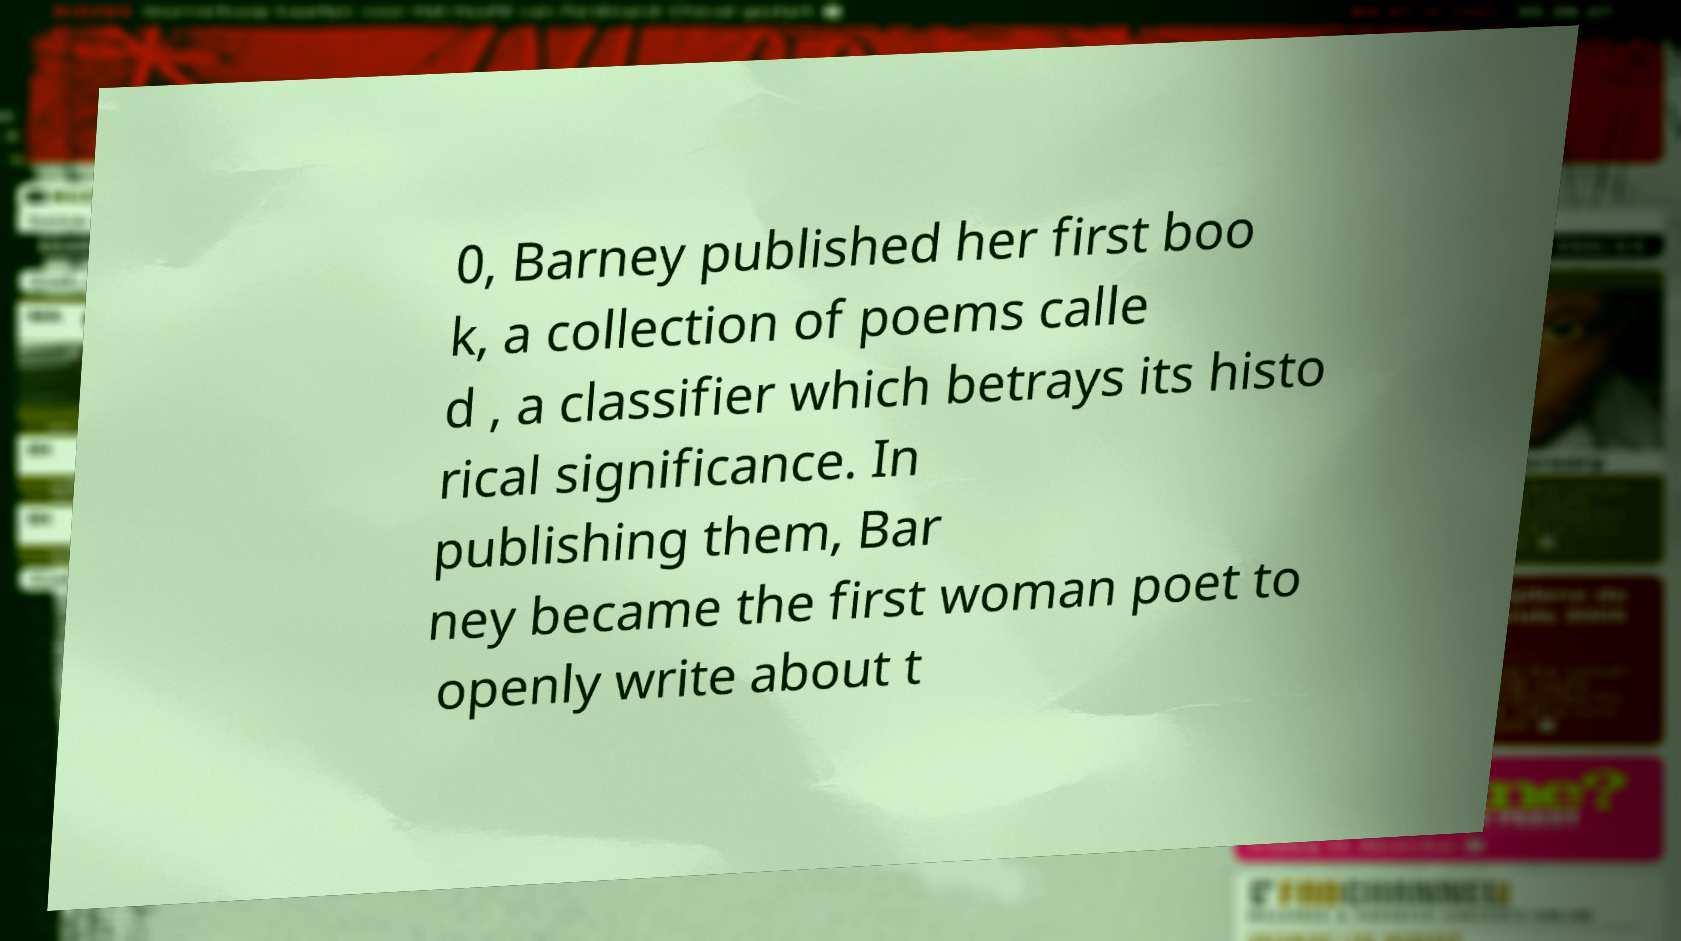Could you assist in decoding the text presented in this image and type it out clearly? 0, Barney published her first boo k, a collection of poems calle d , a classifier which betrays its histo rical significance. In publishing them, Bar ney became the first woman poet to openly write about t 